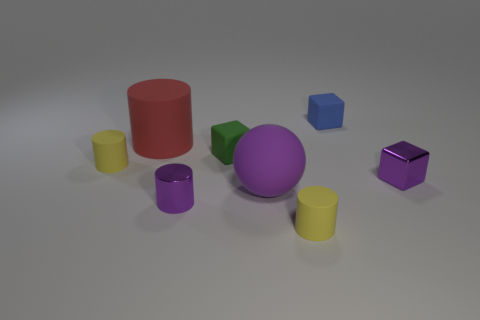Subtract all matte cubes. How many cubes are left? 1 Add 2 small green rubber things. How many objects exist? 10 Subtract 1 balls. How many balls are left? 0 Subtract all yellow cylinders. How many cylinders are left? 2 Subtract all spheres. How many objects are left? 7 Subtract all red balls. How many cyan blocks are left? 0 Subtract all purple objects. Subtract all tiny red matte balls. How many objects are left? 5 Add 1 big red things. How many big red things are left? 2 Add 6 large gray blocks. How many large gray blocks exist? 6 Subtract 0 cyan balls. How many objects are left? 8 